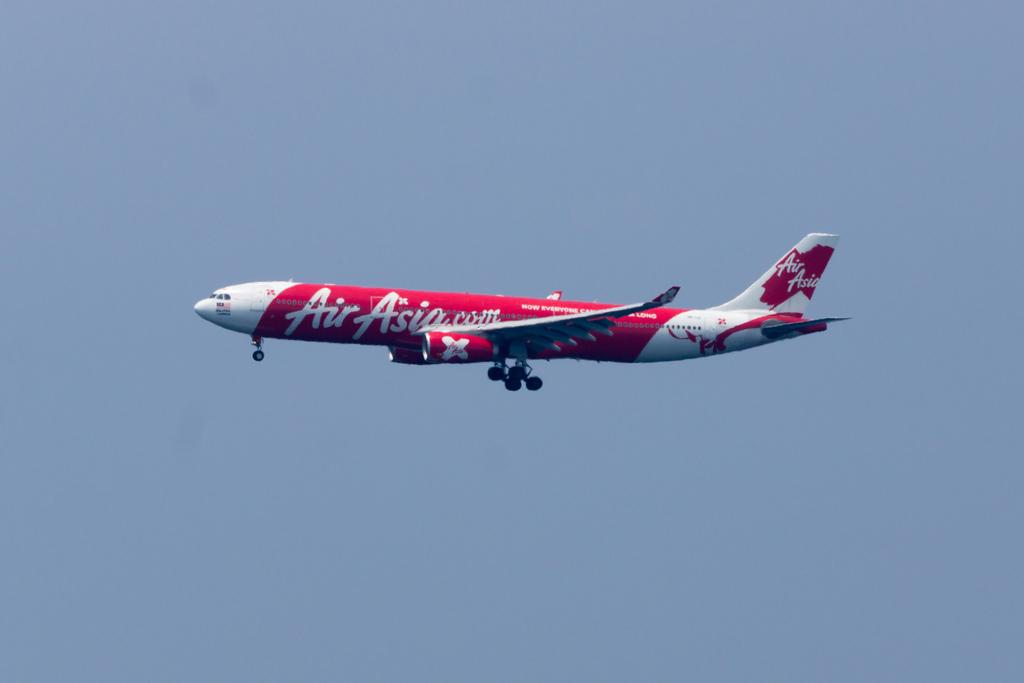What is the main subject of the image? There is an aeroplane in the center of the image. What can be seen in the background of the image? There is sky visible in the background of the image. How many flocks of silk are present in the image? There are no flocks of silk present in the image. What need does the aeroplane have in the image? The image does not provide information about the aeroplane's needs. 